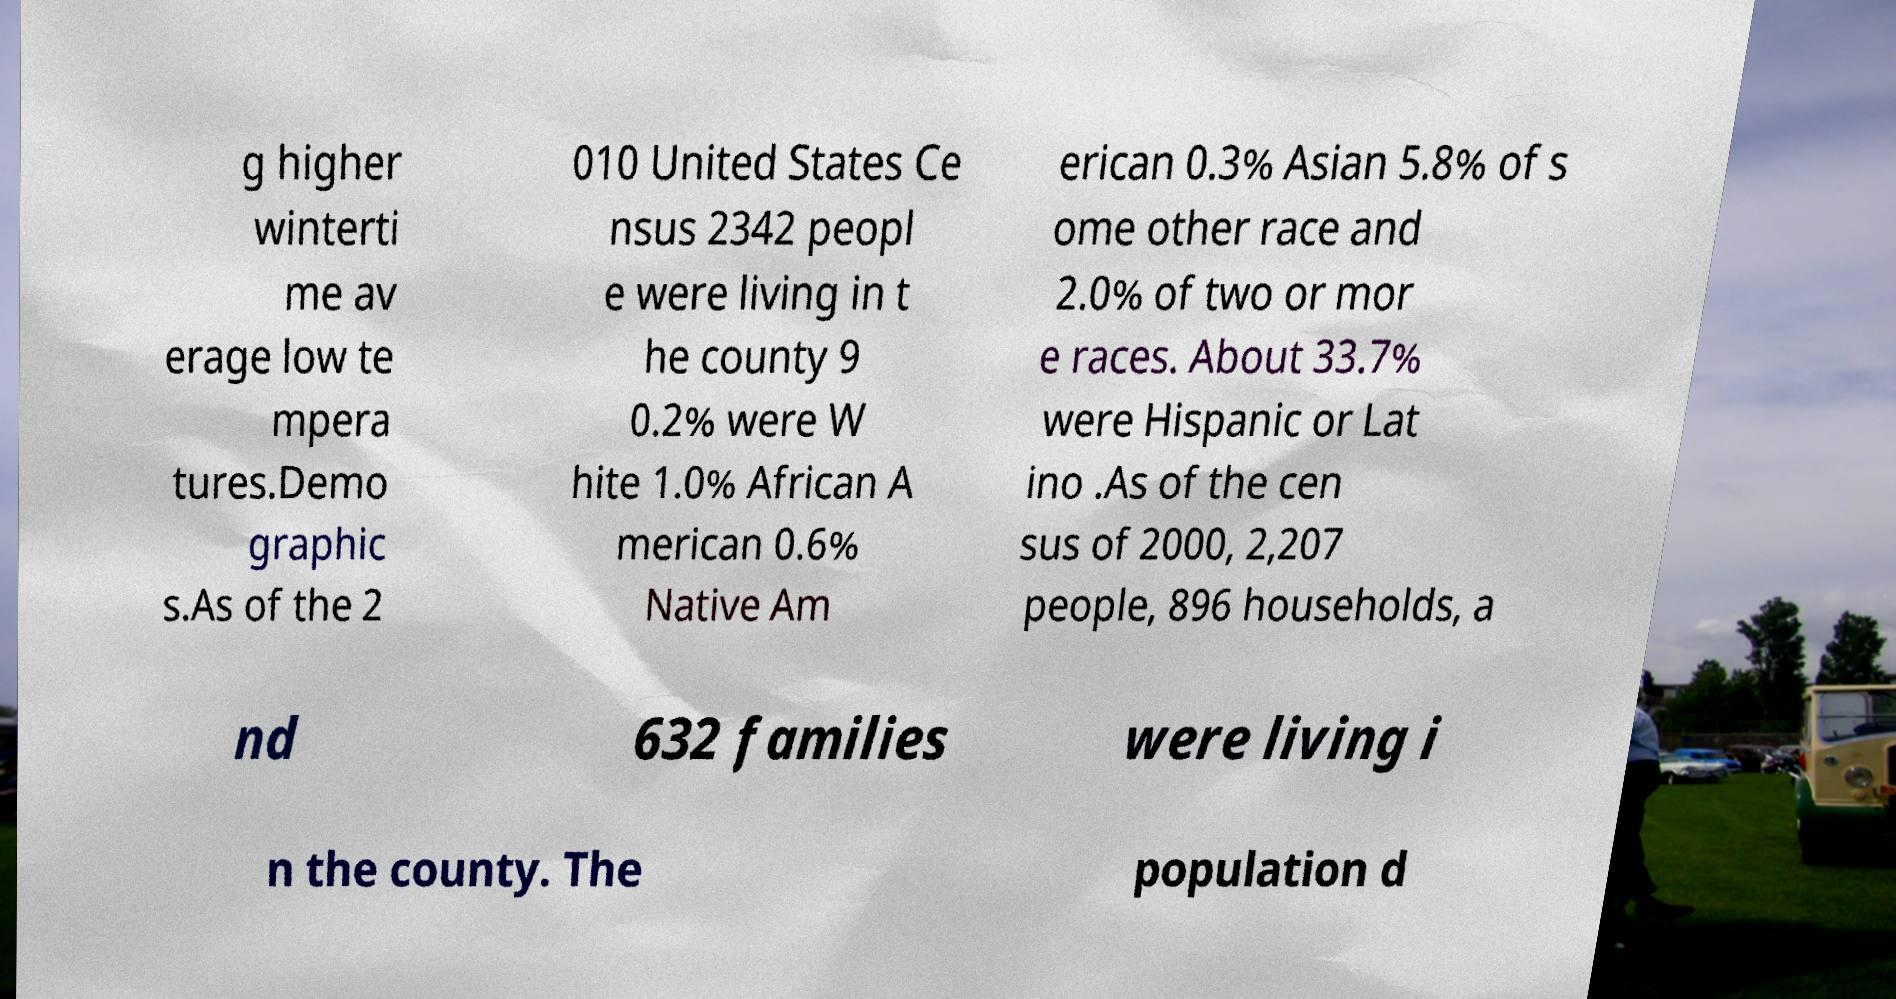What messages or text are displayed in this image? I need them in a readable, typed format. g higher winterti me av erage low te mpera tures.Demo graphic s.As of the 2 010 United States Ce nsus 2342 peopl e were living in t he county 9 0.2% were W hite 1.0% African A merican 0.6% Native Am erican 0.3% Asian 5.8% of s ome other race and 2.0% of two or mor e races. About 33.7% were Hispanic or Lat ino .As of the cen sus of 2000, 2,207 people, 896 households, a nd 632 families were living i n the county. The population d 